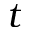Convert formula to latex. <formula><loc_0><loc_0><loc_500><loc_500>t</formula> 